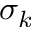<formula> <loc_0><loc_0><loc_500><loc_500>\sigma _ { k }</formula> 